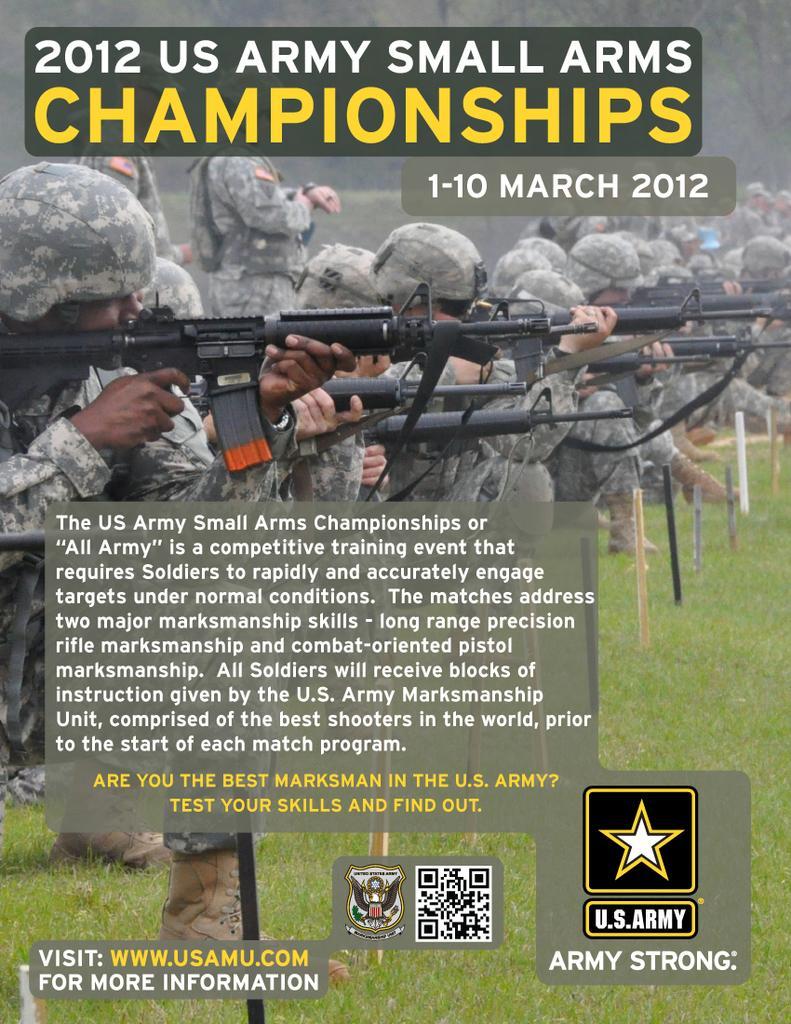How would you summarize this image in a sentence or two? In this image we can see a picture of a group of persons standing on a grass field wearing military uniforms and caps. Some persons are holding guns with their hands. In the background, we can see some sticks, logos and some text. 